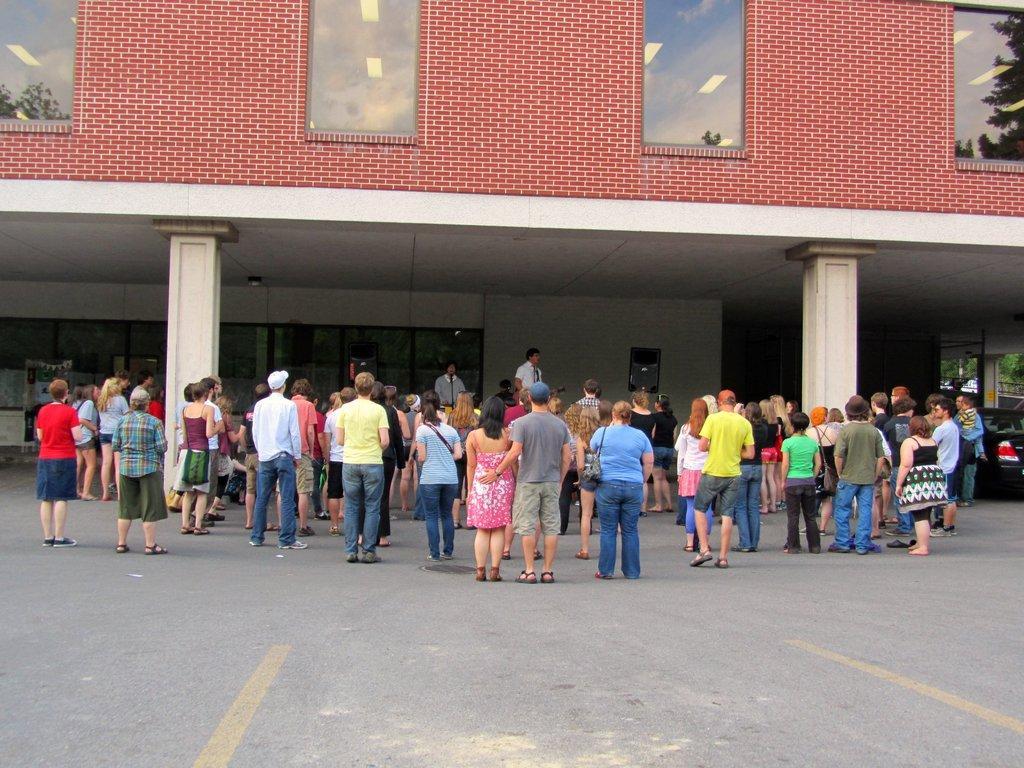Could you give a brief overview of what you see in this image? In this image I can see few group of people standing and few are wearing bags. Back I can see a building, windows, pillars and vehicle. 